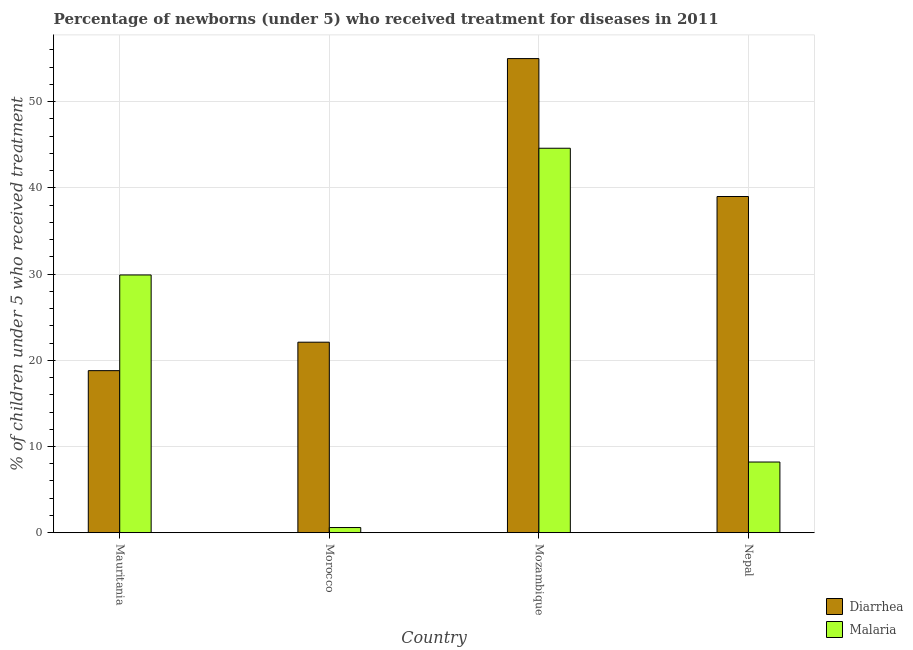How many different coloured bars are there?
Your response must be concise. 2. How many groups of bars are there?
Keep it short and to the point. 4. Are the number of bars per tick equal to the number of legend labels?
Offer a very short reply. Yes. Are the number of bars on each tick of the X-axis equal?
Provide a succinct answer. Yes. How many bars are there on the 2nd tick from the right?
Give a very brief answer. 2. What is the label of the 1st group of bars from the left?
Provide a succinct answer. Mauritania. In how many cases, is the number of bars for a given country not equal to the number of legend labels?
Ensure brevity in your answer.  0. What is the percentage of children who received treatment for malaria in Nepal?
Make the answer very short. 8.2. Across all countries, what is the maximum percentage of children who received treatment for malaria?
Your answer should be very brief. 44.6. In which country was the percentage of children who received treatment for malaria maximum?
Keep it short and to the point. Mozambique. In which country was the percentage of children who received treatment for malaria minimum?
Your answer should be compact. Morocco. What is the total percentage of children who received treatment for diarrhoea in the graph?
Keep it short and to the point. 134.9. What is the difference between the percentage of children who received treatment for diarrhoea in Morocco and that in Mozambique?
Offer a very short reply. -32.9. What is the difference between the percentage of children who received treatment for diarrhoea in Mauritania and the percentage of children who received treatment for malaria in Nepal?
Ensure brevity in your answer.  10.6. What is the average percentage of children who received treatment for malaria per country?
Offer a very short reply. 20.82. What is the difference between the percentage of children who received treatment for malaria and percentage of children who received treatment for diarrhoea in Mozambique?
Your response must be concise. -10.4. What is the ratio of the percentage of children who received treatment for malaria in Mozambique to that in Nepal?
Keep it short and to the point. 5.44. Is the percentage of children who received treatment for malaria in Mozambique less than that in Nepal?
Make the answer very short. No. What is the difference between the highest and the lowest percentage of children who received treatment for diarrhoea?
Your answer should be very brief. 36.2. In how many countries, is the percentage of children who received treatment for malaria greater than the average percentage of children who received treatment for malaria taken over all countries?
Your answer should be compact. 2. What does the 2nd bar from the left in Mozambique represents?
Make the answer very short. Malaria. What does the 2nd bar from the right in Mozambique represents?
Provide a short and direct response. Diarrhea. How many bars are there?
Your answer should be very brief. 8. How many countries are there in the graph?
Offer a terse response. 4. Are the values on the major ticks of Y-axis written in scientific E-notation?
Provide a short and direct response. No. Does the graph contain any zero values?
Your answer should be compact. No. Does the graph contain grids?
Offer a terse response. Yes. Where does the legend appear in the graph?
Offer a terse response. Bottom right. What is the title of the graph?
Make the answer very short. Percentage of newborns (under 5) who received treatment for diseases in 2011. Does "Non-resident workers" appear as one of the legend labels in the graph?
Keep it short and to the point. No. What is the label or title of the X-axis?
Your answer should be compact. Country. What is the label or title of the Y-axis?
Ensure brevity in your answer.  % of children under 5 who received treatment. What is the % of children under 5 who received treatment in Diarrhea in Mauritania?
Provide a succinct answer. 18.8. What is the % of children under 5 who received treatment in Malaria in Mauritania?
Ensure brevity in your answer.  29.9. What is the % of children under 5 who received treatment in Diarrhea in Morocco?
Your response must be concise. 22.1. What is the % of children under 5 who received treatment in Malaria in Morocco?
Your answer should be very brief. 0.6. What is the % of children under 5 who received treatment in Diarrhea in Mozambique?
Offer a terse response. 55. What is the % of children under 5 who received treatment in Malaria in Mozambique?
Offer a terse response. 44.6. What is the % of children under 5 who received treatment of Diarrhea in Nepal?
Provide a succinct answer. 39. Across all countries, what is the maximum % of children under 5 who received treatment in Malaria?
Provide a succinct answer. 44.6. Across all countries, what is the minimum % of children under 5 who received treatment in Diarrhea?
Keep it short and to the point. 18.8. Across all countries, what is the minimum % of children under 5 who received treatment in Malaria?
Your response must be concise. 0.6. What is the total % of children under 5 who received treatment in Diarrhea in the graph?
Your response must be concise. 134.9. What is the total % of children under 5 who received treatment of Malaria in the graph?
Keep it short and to the point. 83.3. What is the difference between the % of children under 5 who received treatment in Malaria in Mauritania and that in Morocco?
Make the answer very short. 29.3. What is the difference between the % of children under 5 who received treatment in Diarrhea in Mauritania and that in Mozambique?
Keep it short and to the point. -36.2. What is the difference between the % of children under 5 who received treatment in Malaria in Mauritania and that in Mozambique?
Your answer should be compact. -14.7. What is the difference between the % of children under 5 who received treatment in Diarrhea in Mauritania and that in Nepal?
Provide a short and direct response. -20.2. What is the difference between the % of children under 5 who received treatment of Malaria in Mauritania and that in Nepal?
Offer a very short reply. 21.7. What is the difference between the % of children under 5 who received treatment in Diarrhea in Morocco and that in Mozambique?
Offer a very short reply. -32.9. What is the difference between the % of children under 5 who received treatment in Malaria in Morocco and that in Mozambique?
Offer a terse response. -44. What is the difference between the % of children under 5 who received treatment of Diarrhea in Morocco and that in Nepal?
Offer a terse response. -16.9. What is the difference between the % of children under 5 who received treatment of Malaria in Morocco and that in Nepal?
Give a very brief answer. -7.6. What is the difference between the % of children under 5 who received treatment in Diarrhea in Mozambique and that in Nepal?
Make the answer very short. 16. What is the difference between the % of children under 5 who received treatment of Malaria in Mozambique and that in Nepal?
Your answer should be compact. 36.4. What is the difference between the % of children under 5 who received treatment in Diarrhea in Mauritania and the % of children under 5 who received treatment in Malaria in Morocco?
Provide a short and direct response. 18.2. What is the difference between the % of children under 5 who received treatment in Diarrhea in Mauritania and the % of children under 5 who received treatment in Malaria in Mozambique?
Offer a terse response. -25.8. What is the difference between the % of children under 5 who received treatment in Diarrhea in Mauritania and the % of children under 5 who received treatment in Malaria in Nepal?
Offer a terse response. 10.6. What is the difference between the % of children under 5 who received treatment in Diarrhea in Morocco and the % of children under 5 who received treatment in Malaria in Mozambique?
Provide a short and direct response. -22.5. What is the difference between the % of children under 5 who received treatment of Diarrhea in Mozambique and the % of children under 5 who received treatment of Malaria in Nepal?
Offer a very short reply. 46.8. What is the average % of children under 5 who received treatment in Diarrhea per country?
Provide a short and direct response. 33.73. What is the average % of children under 5 who received treatment of Malaria per country?
Offer a terse response. 20.82. What is the difference between the % of children under 5 who received treatment in Diarrhea and % of children under 5 who received treatment in Malaria in Mauritania?
Offer a very short reply. -11.1. What is the difference between the % of children under 5 who received treatment of Diarrhea and % of children under 5 who received treatment of Malaria in Morocco?
Provide a succinct answer. 21.5. What is the difference between the % of children under 5 who received treatment of Diarrhea and % of children under 5 who received treatment of Malaria in Mozambique?
Offer a terse response. 10.4. What is the difference between the % of children under 5 who received treatment in Diarrhea and % of children under 5 who received treatment in Malaria in Nepal?
Your answer should be compact. 30.8. What is the ratio of the % of children under 5 who received treatment in Diarrhea in Mauritania to that in Morocco?
Offer a terse response. 0.85. What is the ratio of the % of children under 5 who received treatment in Malaria in Mauritania to that in Morocco?
Provide a succinct answer. 49.83. What is the ratio of the % of children under 5 who received treatment of Diarrhea in Mauritania to that in Mozambique?
Provide a succinct answer. 0.34. What is the ratio of the % of children under 5 who received treatment in Malaria in Mauritania to that in Mozambique?
Your response must be concise. 0.67. What is the ratio of the % of children under 5 who received treatment in Diarrhea in Mauritania to that in Nepal?
Make the answer very short. 0.48. What is the ratio of the % of children under 5 who received treatment in Malaria in Mauritania to that in Nepal?
Provide a short and direct response. 3.65. What is the ratio of the % of children under 5 who received treatment of Diarrhea in Morocco to that in Mozambique?
Provide a succinct answer. 0.4. What is the ratio of the % of children under 5 who received treatment of Malaria in Morocco to that in Mozambique?
Ensure brevity in your answer.  0.01. What is the ratio of the % of children under 5 who received treatment in Diarrhea in Morocco to that in Nepal?
Keep it short and to the point. 0.57. What is the ratio of the % of children under 5 who received treatment of Malaria in Morocco to that in Nepal?
Your response must be concise. 0.07. What is the ratio of the % of children under 5 who received treatment of Diarrhea in Mozambique to that in Nepal?
Keep it short and to the point. 1.41. What is the ratio of the % of children under 5 who received treatment in Malaria in Mozambique to that in Nepal?
Offer a terse response. 5.44. What is the difference between the highest and the second highest % of children under 5 who received treatment of Diarrhea?
Offer a terse response. 16. What is the difference between the highest and the lowest % of children under 5 who received treatment in Diarrhea?
Offer a very short reply. 36.2. What is the difference between the highest and the lowest % of children under 5 who received treatment in Malaria?
Keep it short and to the point. 44. 